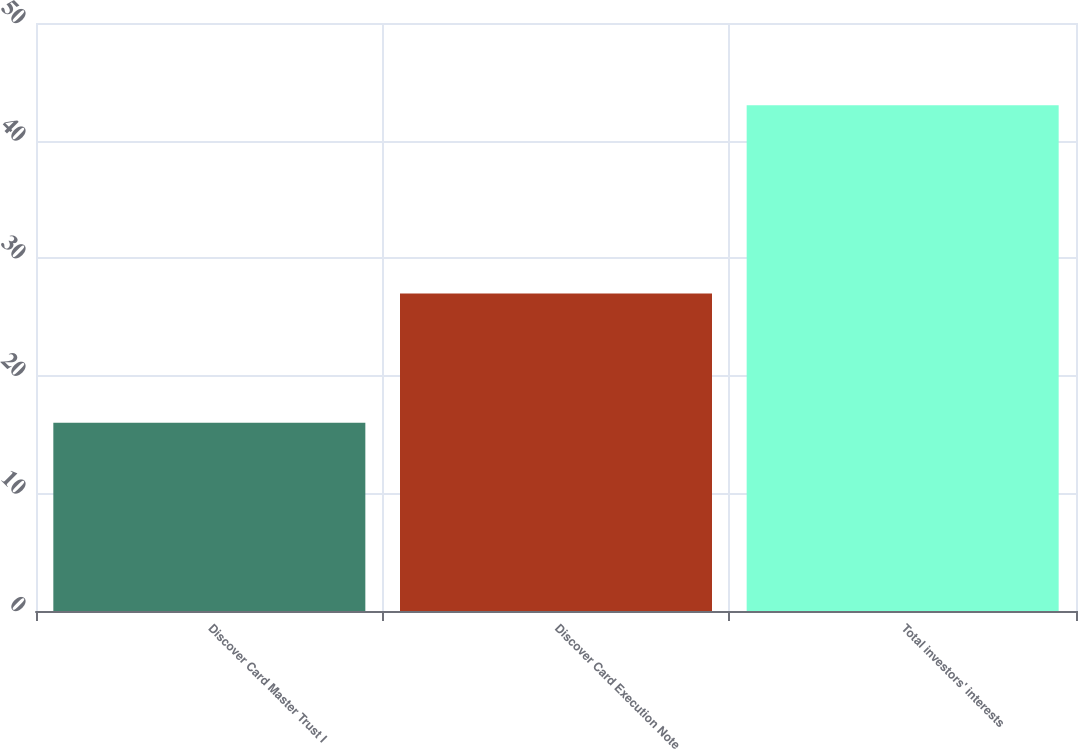Convert chart to OTSL. <chart><loc_0><loc_0><loc_500><loc_500><bar_chart><fcel>Discover Card Master Trust I<fcel>Discover Card Execution Note<fcel>Total investors' interests<nl><fcel>16<fcel>27<fcel>43<nl></chart> 